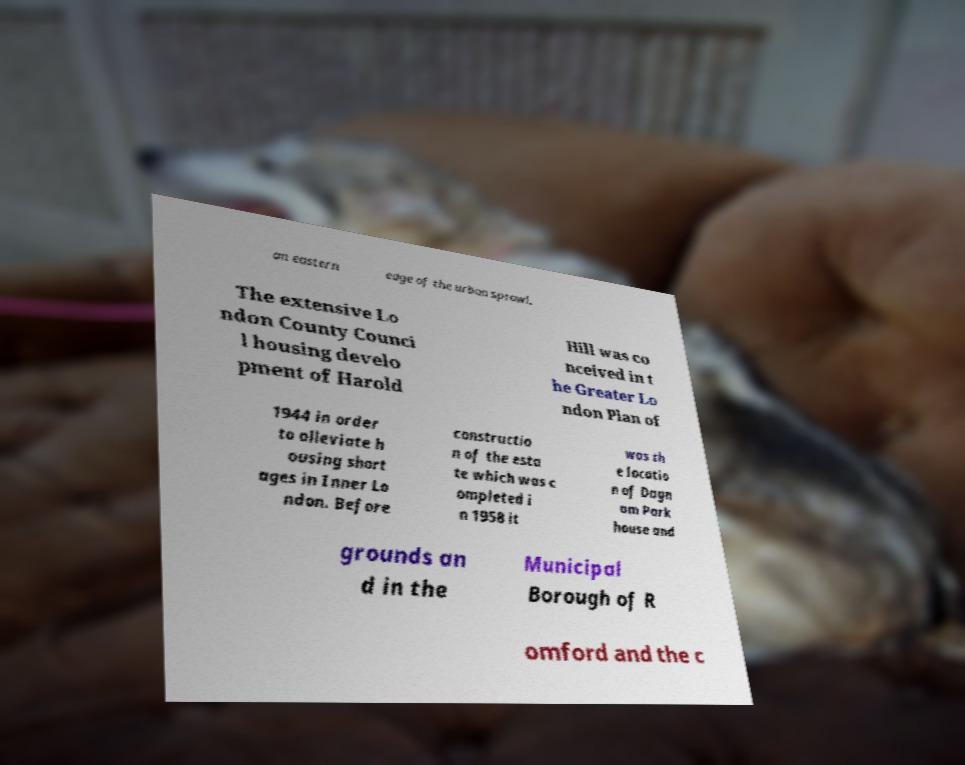Please identify and transcribe the text found in this image. an eastern edge of the urban sprawl. The extensive Lo ndon County Counci l housing develo pment of Harold Hill was co nceived in t he Greater Lo ndon Plan of 1944 in order to alleviate h ousing short ages in Inner Lo ndon. Before constructio n of the esta te which was c ompleted i n 1958 it was th e locatio n of Dagn am Park house and grounds an d in the Municipal Borough of R omford and the c 